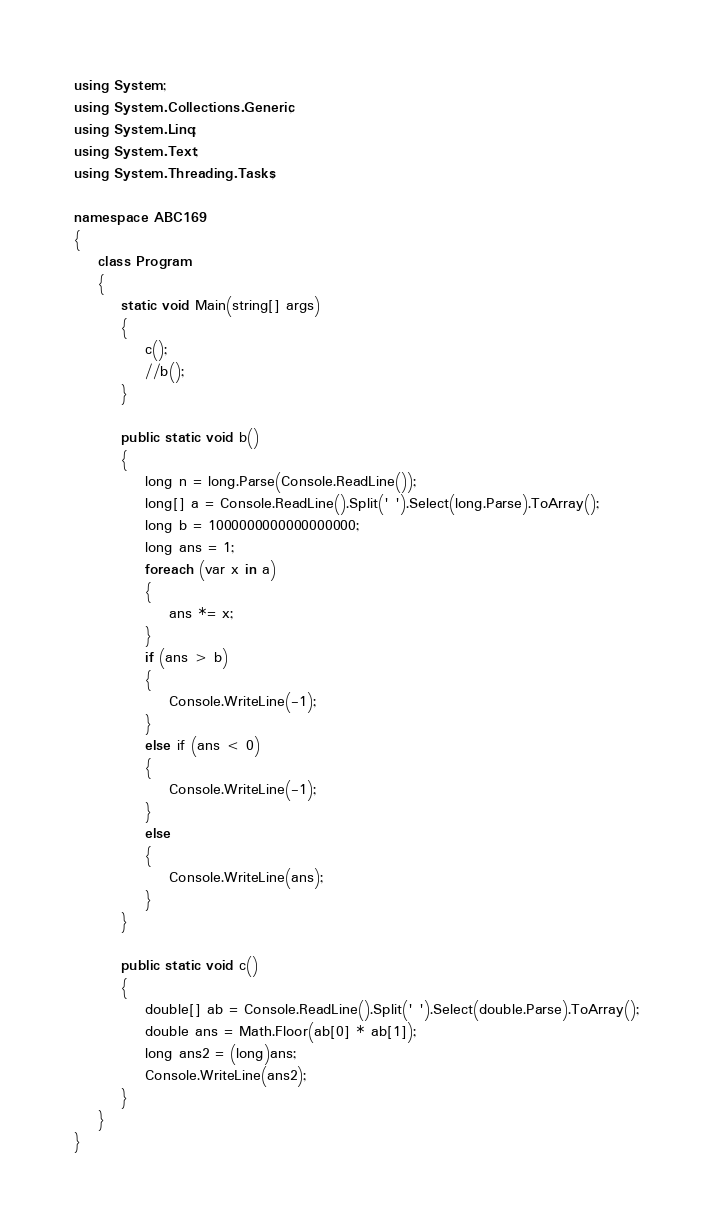<code> <loc_0><loc_0><loc_500><loc_500><_C#_>using System;
using System.Collections.Generic;
using System.Linq;
using System.Text;
using System.Threading.Tasks;

namespace ABC169
{
    class Program
    {
        static void Main(string[] args)
        {
            c();
            //b();
        }

        public static void b()
        {
            long n = long.Parse(Console.ReadLine());
            long[] a = Console.ReadLine().Split(' ').Select(long.Parse).ToArray();
            long b = 1000000000000000000;
            long ans = 1;
            foreach (var x in a)
            {
                ans *= x;
            }
            if (ans > b)
            {
                Console.WriteLine(-1);
            }
            else if (ans < 0)
            {
                Console.WriteLine(-1);
            }
            else
            {
                Console.WriteLine(ans);
            }
        }

        public static void c()
        {
            double[] ab = Console.ReadLine().Split(' ').Select(double.Parse).ToArray();
            double ans = Math.Floor(ab[0] * ab[1]);
            long ans2 = (long)ans;
            Console.WriteLine(ans2);
        }
    }
}
</code> 